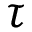Convert formula to latex. <formula><loc_0><loc_0><loc_500><loc_500>\tau</formula> 